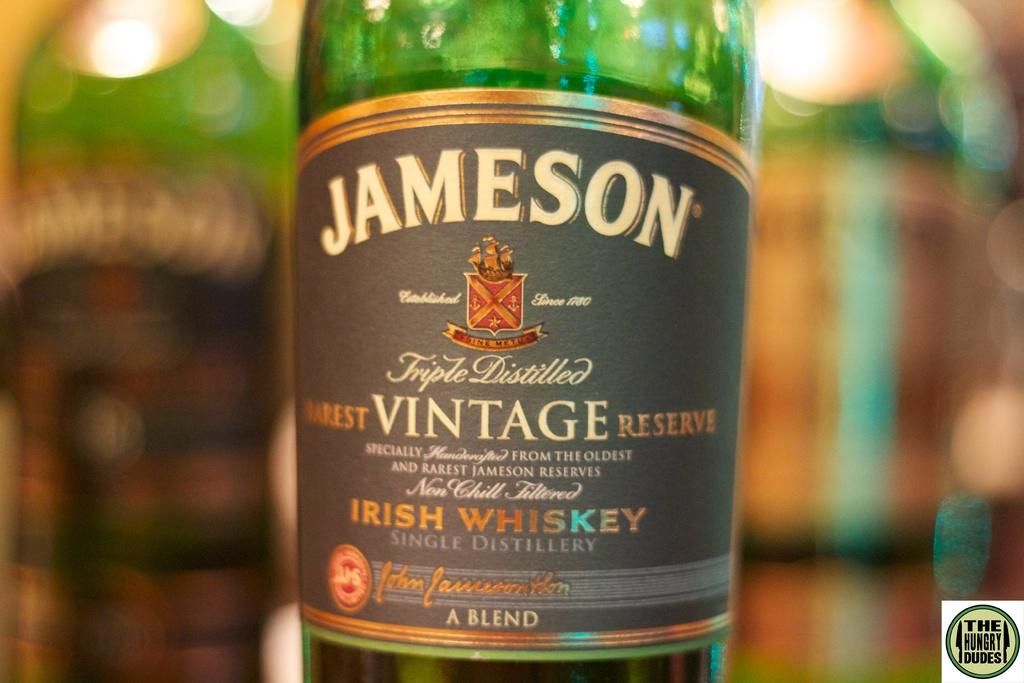<image>
Offer a succinct explanation of the picture presented. A close up of the label on a Jameson Vintage Irish Whiskey bottle 